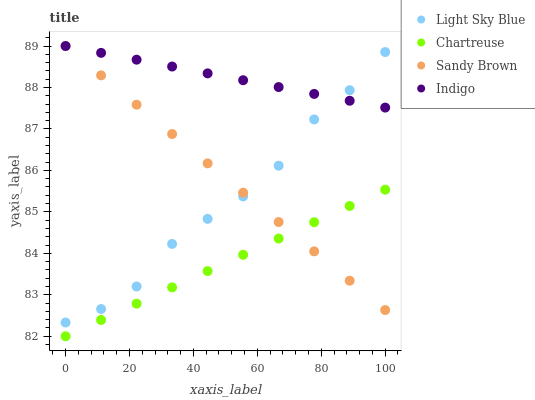Does Chartreuse have the minimum area under the curve?
Answer yes or no. Yes. Does Indigo have the maximum area under the curve?
Answer yes or no. Yes. Does Light Sky Blue have the minimum area under the curve?
Answer yes or no. No. Does Light Sky Blue have the maximum area under the curve?
Answer yes or no. No. Is Sandy Brown the smoothest?
Answer yes or no. Yes. Is Light Sky Blue the roughest?
Answer yes or no. Yes. Is Chartreuse the smoothest?
Answer yes or no. No. Is Chartreuse the roughest?
Answer yes or no. No. Does Chartreuse have the lowest value?
Answer yes or no. Yes. Does Light Sky Blue have the lowest value?
Answer yes or no. No. Does Sandy Brown have the highest value?
Answer yes or no. Yes. Does Light Sky Blue have the highest value?
Answer yes or no. No. Is Chartreuse less than Light Sky Blue?
Answer yes or no. Yes. Is Light Sky Blue greater than Chartreuse?
Answer yes or no. Yes. Does Indigo intersect Sandy Brown?
Answer yes or no. Yes. Is Indigo less than Sandy Brown?
Answer yes or no. No. Is Indigo greater than Sandy Brown?
Answer yes or no. No. Does Chartreuse intersect Light Sky Blue?
Answer yes or no. No. 